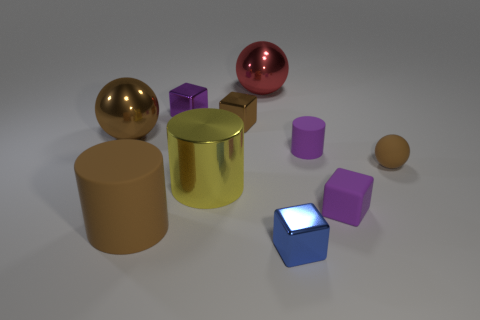How many large objects are yellow metallic objects or brown balls?
Give a very brief answer. 2. The tiny rubber object that is the same color as the small matte cube is what shape?
Make the answer very short. Cylinder. Is the tiny brown thing behind the rubber ball made of the same material as the blue object?
Your answer should be compact. Yes. What material is the large brown thing in front of the ball that is right of the large red thing?
Your answer should be very brief. Rubber. How many blue objects have the same shape as the tiny purple metal object?
Your response must be concise. 1. There is a purple cube behind the brown cube right of the small purple cube that is behind the rubber block; what is its size?
Keep it short and to the point. Small. What number of purple objects are shiny cubes or big rubber things?
Provide a succinct answer. 1. There is a big brown shiny thing that is behind the tiny blue thing; is its shape the same as the tiny brown rubber object?
Give a very brief answer. Yes. Are there more yellow cylinders left of the tiny brown matte ball than big green matte cylinders?
Your answer should be very brief. Yes. How many rubber objects are the same size as the purple shiny cube?
Give a very brief answer. 3. 